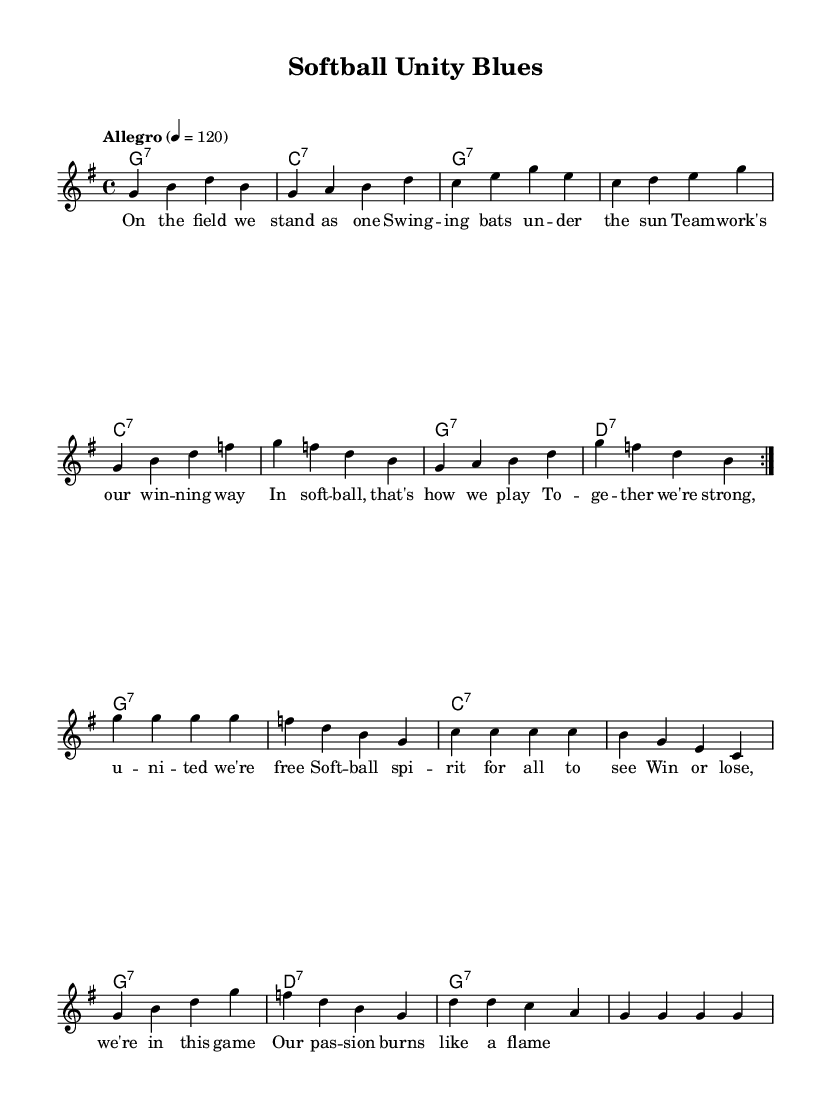What is the key signature of this music? The key signature is G major, which has one sharp (F#) and can be identified at the beginning of the staff.
Answer: G major What is the time signature of this music? The time signature is 4/4, which can be seen at the beginning of the piece, indicating that there are four beats in each measure.
Answer: 4/4 What is the tempo indication for this music? The tempo indication "Allegro" at the beginning suggests a fast pace, specifically 120 beats per minute.
Answer: Allegro How many measures are in the first section of the melody? The first section of the melody, marked by the repeated volta, contains eight measures before the break, identifiable by the repeat signs.
Answer: Eight measures Which chord is played in the first measure? The first measure contains a G7 chord, as indicated by the chord names directly above the staff at the beginning of the piece.
Answer: G7 What lyrical theme is expressed in the song? The lyrics emphasize teamwork and unity, celebrating the spirit of camaraderie in playing softball, as seen throughout the text.
Answer: Teamwork and unity How many times is the phrase “In softball, that’s how we play” repeated in the lyrics? The phrase is unique in the lyrics and appears only once within the context of the overall message of teamwork and camaraderie.
Answer: Once 